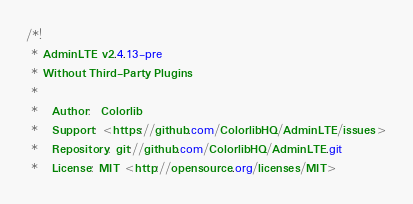Convert code to text. <code><loc_0><loc_0><loc_500><loc_500><_CSS_>/*!
 * AdminLTE v2.4.13-pre
 * Without Third-Party Plugins
 * 
 *   Author:  Colorlib
 *   Support: <https://github.com/ColorlibHQ/AdminLTE/issues>
 *   Repository: git://github.com/ColorlibHQ/AdminLTE.git
 *   License: MIT <http://opensource.org/licenses/MIT></code> 